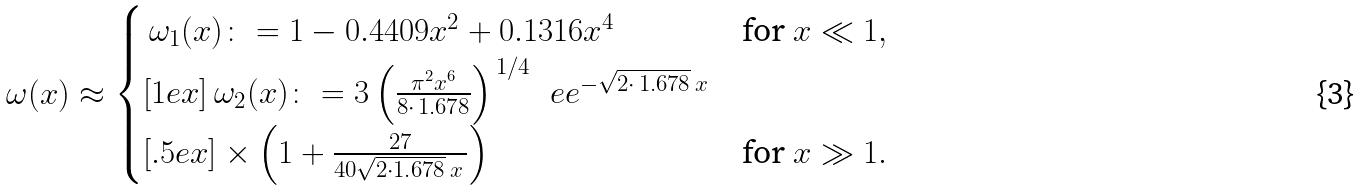Convert formula to latex. <formula><loc_0><loc_0><loc_500><loc_500>\omega ( x ) \approx \begin{cases} \, \omega _ { 1 } ( x ) \colon = 1 - 0 . 4 4 0 9 x ^ { 2 } + 0 . 1 3 1 6 x ^ { 4 } & \text {for } x \ll 1 , \\ [ 1 e x ] \, \omega _ { 2 } ( x ) \colon = 3 \left ( \frac { \pi ^ { 2 } x ^ { 6 } } { 8 \cdot \, 1 . 6 7 8 } \right ) ^ { \, 1 / 4 } \, \ e e ^ { - \sqrt { 2 \cdot \, 1 . 6 7 8 } \, x } \\ [ . 5 e x ] \times \left ( 1 + \frac { 2 7 } { 4 0 \sqrt { 2 \cdot 1 . 6 7 8 } \, x \, } \right ) & \text {for } x \gg 1 . \\ \end{cases}</formula> 